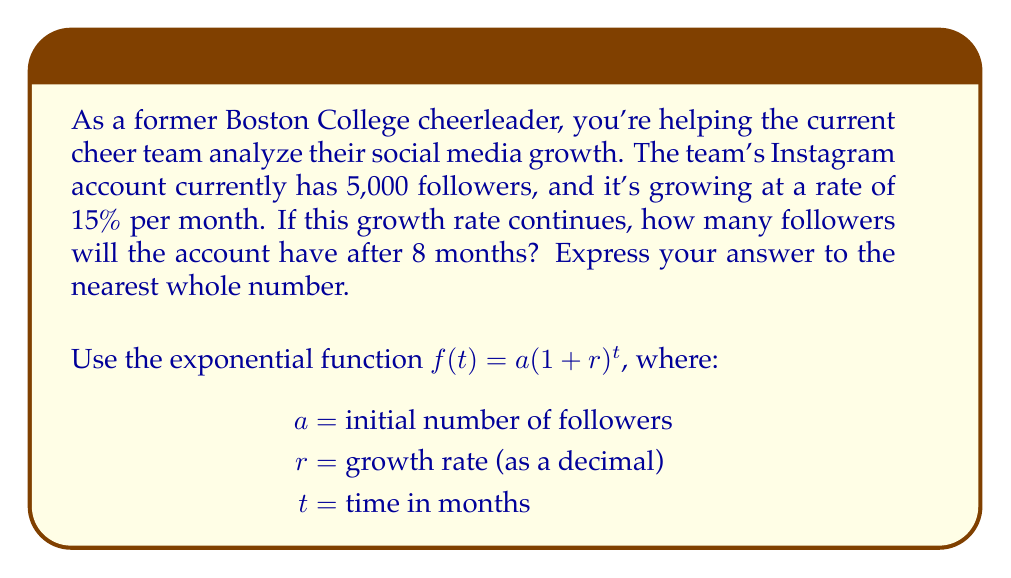Can you answer this question? Let's approach this step-by-step:

1) We're given:
   $a = 5,000$ (initial number of followers)
   $r = 15\% = 0.15$ (growth rate as a decimal)
   $t = 8$ (months)

2) We'll use the exponential growth function:
   $f(t) = a(1 + r)^t$

3) Substituting our values:
   $f(8) = 5000(1 + 0.15)^8$

4) Simplify inside the parentheses:
   $f(8) = 5000(1.15)^8$

5) Calculate $(1.15)^8$:
   $(1.15)^8 \approx 3.0590$

6) Multiply by 5000:
   $5000 * 3.0590 = 15,295$

7) Rounding to the nearest whole number:
   $15,295 \approx 15,295$ followers

Therefore, after 8 months, the cheer team's Instagram account will have approximately 15,295 followers if the growth rate remains constant.
Answer: 15,295 followers 